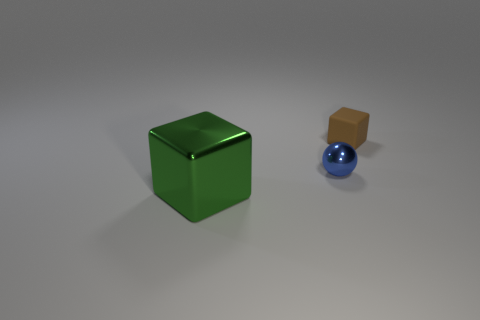Is there any other thing that is the same size as the green block?
Offer a terse response. No. There is a object that is to the right of the large object and in front of the small cube; what is its material?
Your answer should be compact. Metal. What number of blue shiny balls are on the right side of the green thing?
Offer a very short reply. 1. Is the large green object left of the small blue metal ball made of the same material as the tiny thing that is right of the small blue shiny ball?
Your response must be concise. No. How many objects are either blocks right of the green metallic cube or big yellow shiny cubes?
Offer a very short reply. 1. Are there fewer big green things that are to the right of the brown matte object than tiny balls to the left of the large green metallic block?
Offer a terse response. No. How many other objects are the same size as the brown block?
Your answer should be very brief. 1. Is the small blue ball made of the same material as the small thing that is behind the small blue thing?
Give a very brief answer. No. How many objects are either objects right of the shiny cube or small things that are to the left of the tiny brown rubber thing?
Give a very brief answer. 2. What color is the rubber cube?
Give a very brief answer. Brown. 